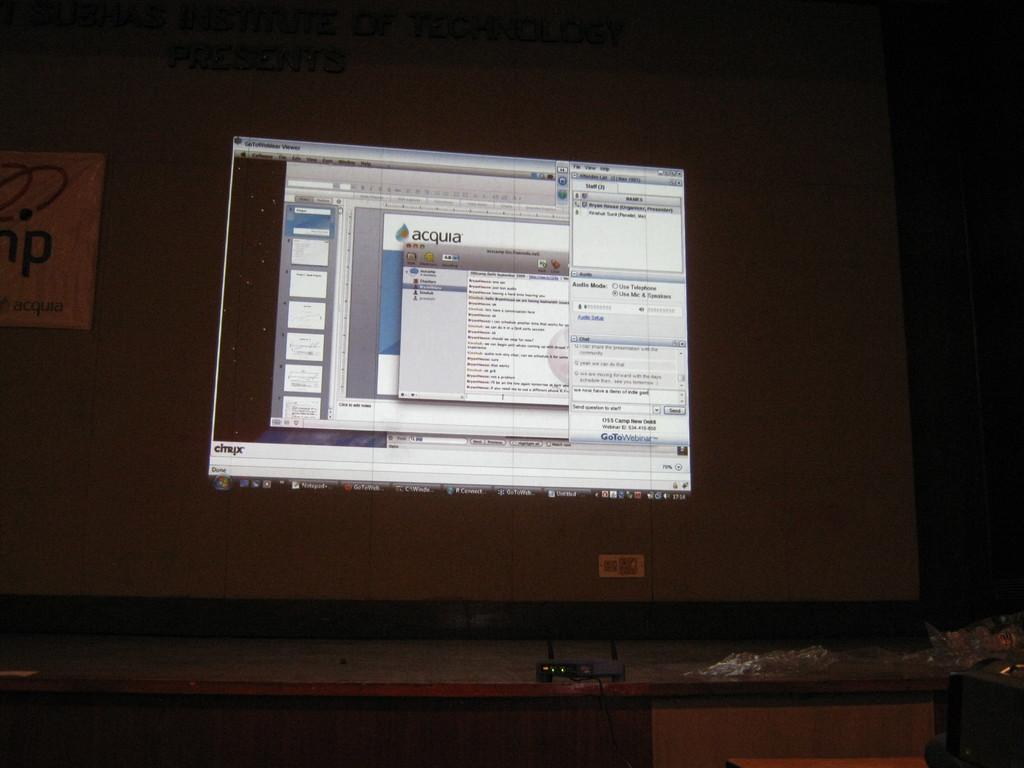What webpage is this?
Ensure brevity in your answer.  Acquia. What's the last letter of the banner on the left?
Your response must be concise. P. 